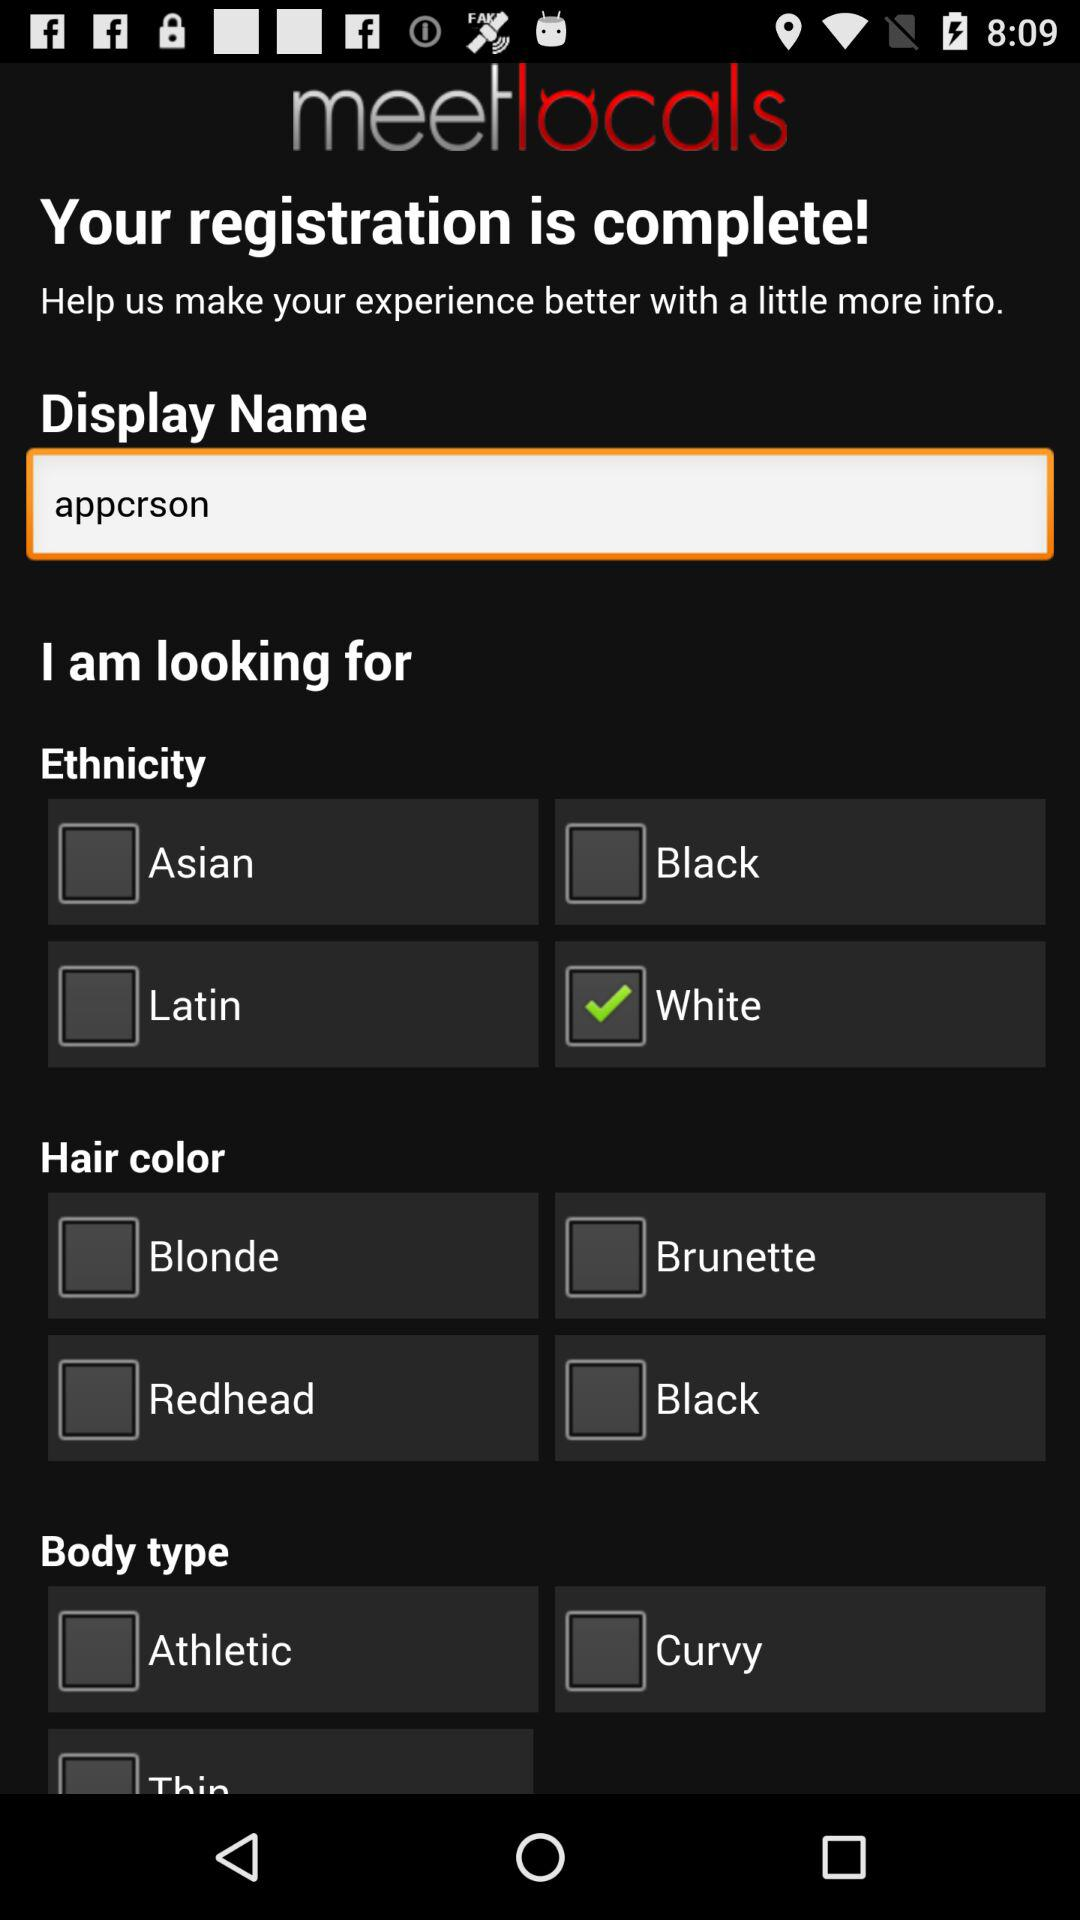What is the application name? The application name is "meetlocals". 